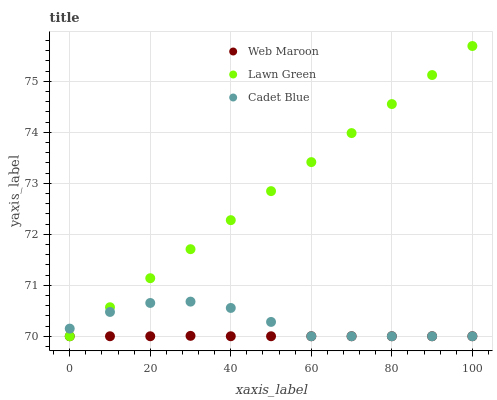Does Web Maroon have the minimum area under the curve?
Answer yes or no. Yes. Does Lawn Green have the maximum area under the curve?
Answer yes or no. Yes. Does Cadet Blue have the minimum area under the curve?
Answer yes or no. No. Does Cadet Blue have the maximum area under the curve?
Answer yes or no. No. Is Lawn Green the smoothest?
Answer yes or no. Yes. Is Cadet Blue the roughest?
Answer yes or no. Yes. Is Web Maroon the smoothest?
Answer yes or no. No. Is Web Maroon the roughest?
Answer yes or no. No. Does Lawn Green have the lowest value?
Answer yes or no. Yes. Does Lawn Green have the highest value?
Answer yes or no. Yes. Does Cadet Blue have the highest value?
Answer yes or no. No. Does Cadet Blue intersect Web Maroon?
Answer yes or no. Yes. Is Cadet Blue less than Web Maroon?
Answer yes or no. No. Is Cadet Blue greater than Web Maroon?
Answer yes or no. No. 